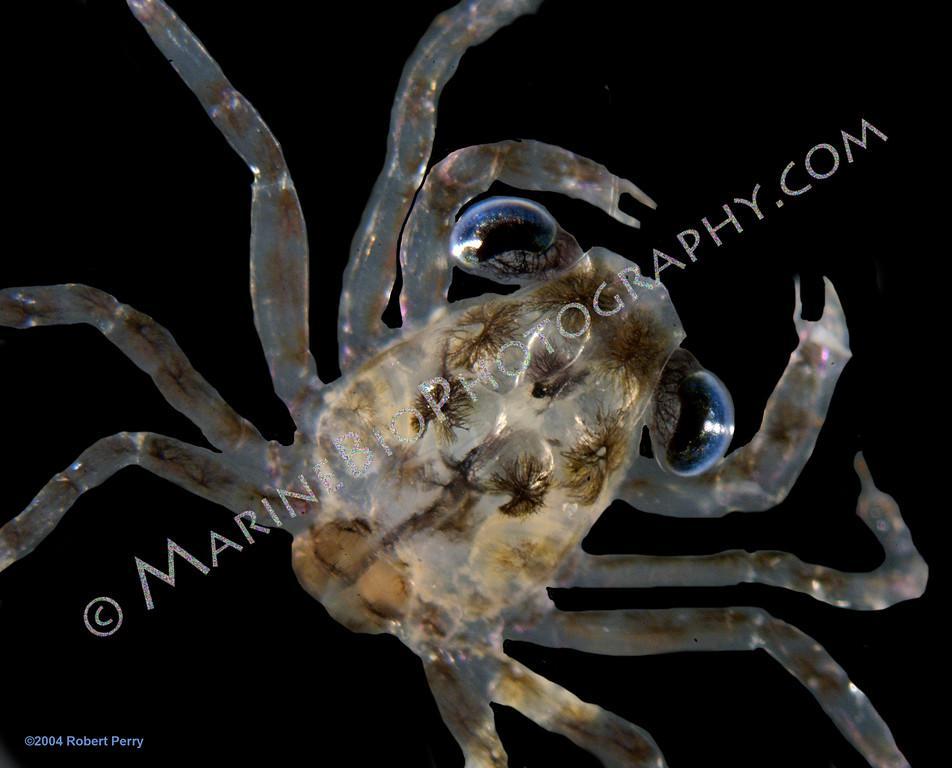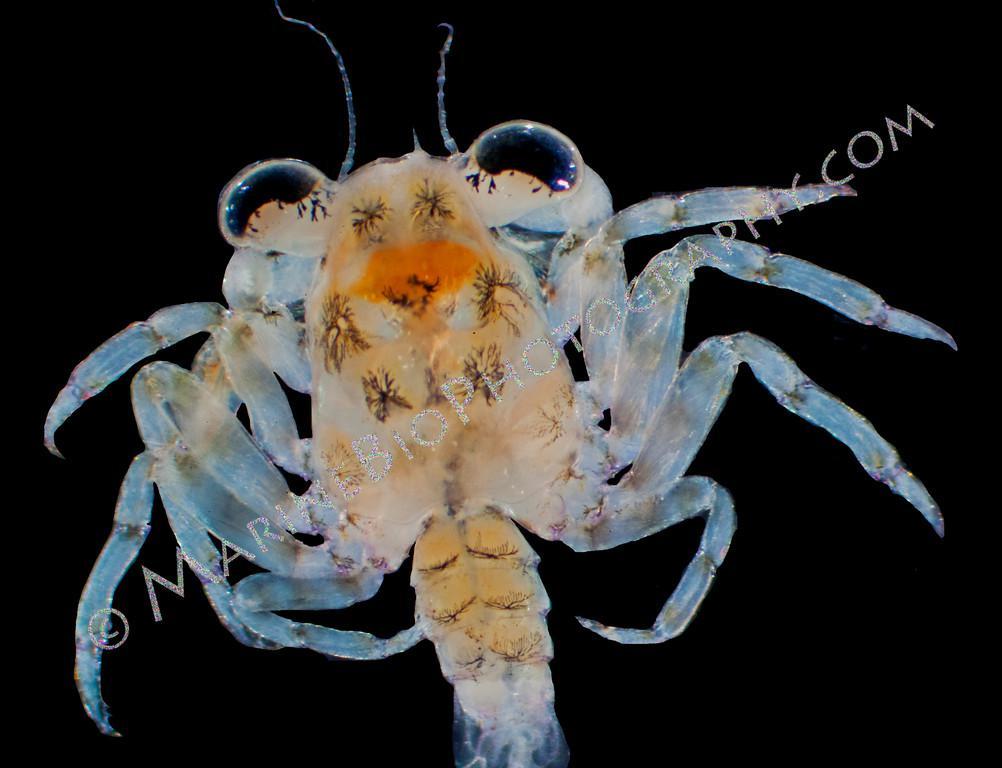The first image is the image on the left, the second image is the image on the right. For the images displayed, is the sentence "Each image contains one many-legged creature, but the creatures depicted on the left and right do not have the same body shape and are not facing in the same direction." factually correct? Answer yes or no. Yes. The first image is the image on the left, the second image is the image on the right. Given the left and right images, does the statement "Two pairs of pincers are visible." hold true? Answer yes or no. No. 